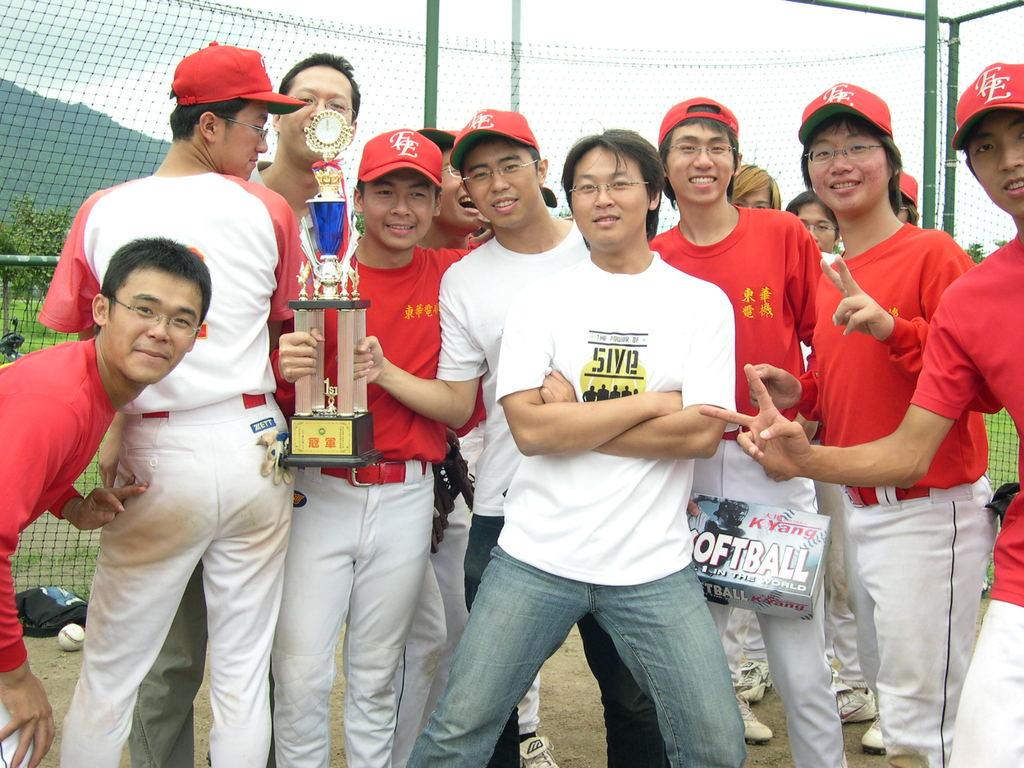What is displayed on the man's shirt in the middle?
Provide a short and direct response. 5ive. What sport does this team play?
Your answer should be very brief. Softball. 